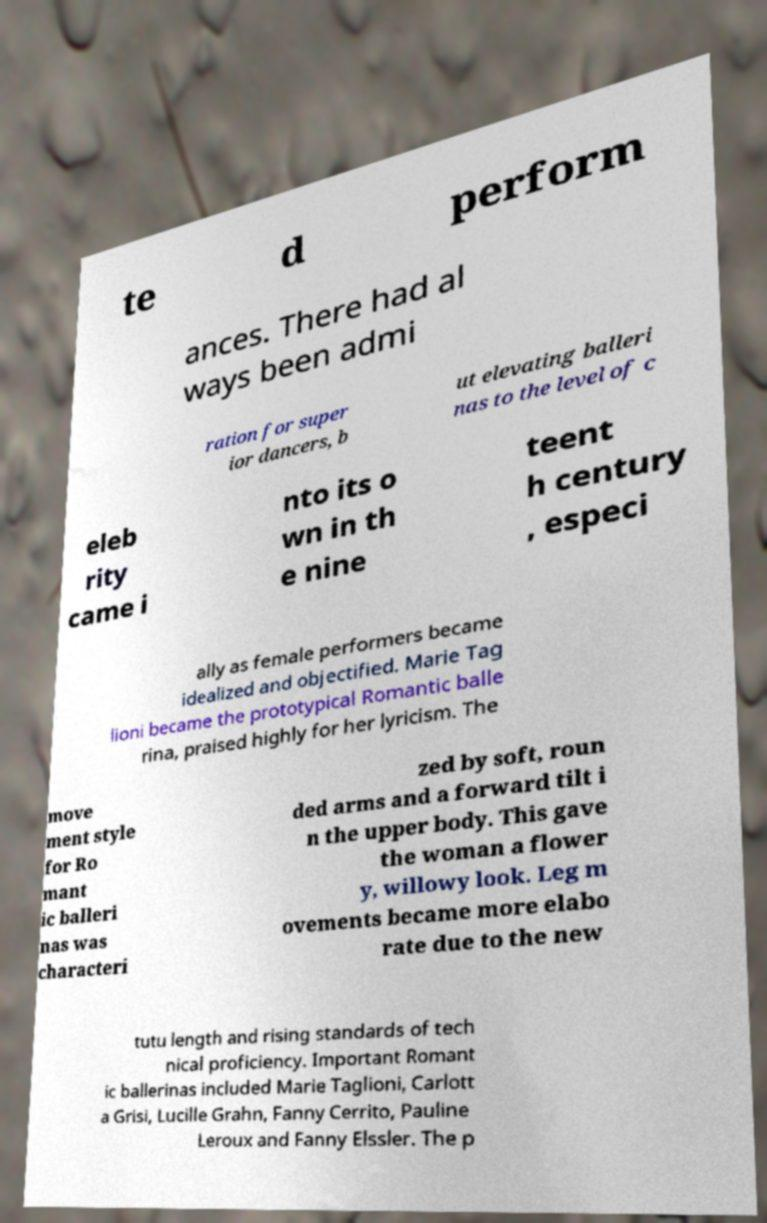What messages or text are displayed in this image? I need them in a readable, typed format. te d perform ances. There had al ways been admi ration for super ior dancers, b ut elevating balleri nas to the level of c eleb rity came i nto its o wn in th e nine teent h century , especi ally as female performers became idealized and objectified. Marie Tag lioni became the prototypical Romantic balle rina, praised highly for her lyricism. The move ment style for Ro mant ic balleri nas was characteri zed by soft, roun ded arms and a forward tilt i n the upper body. This gave the woman a flower y, willowy look. Leg m ovements became more elabo rate due to the new tutu length and rising standards of tech nical proficiency. Important Romant ic ballerinas included Marie Taglioni, Carlott a Grisi, Lucille Grahn, Fanny Cerrito, Pauline Leroux and Fanny Elssler. The p 